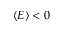Convert formula to latex. <formula><loc_0><loc_0><loc_500><loc_500>\langle E \rangle < 0</formula> 